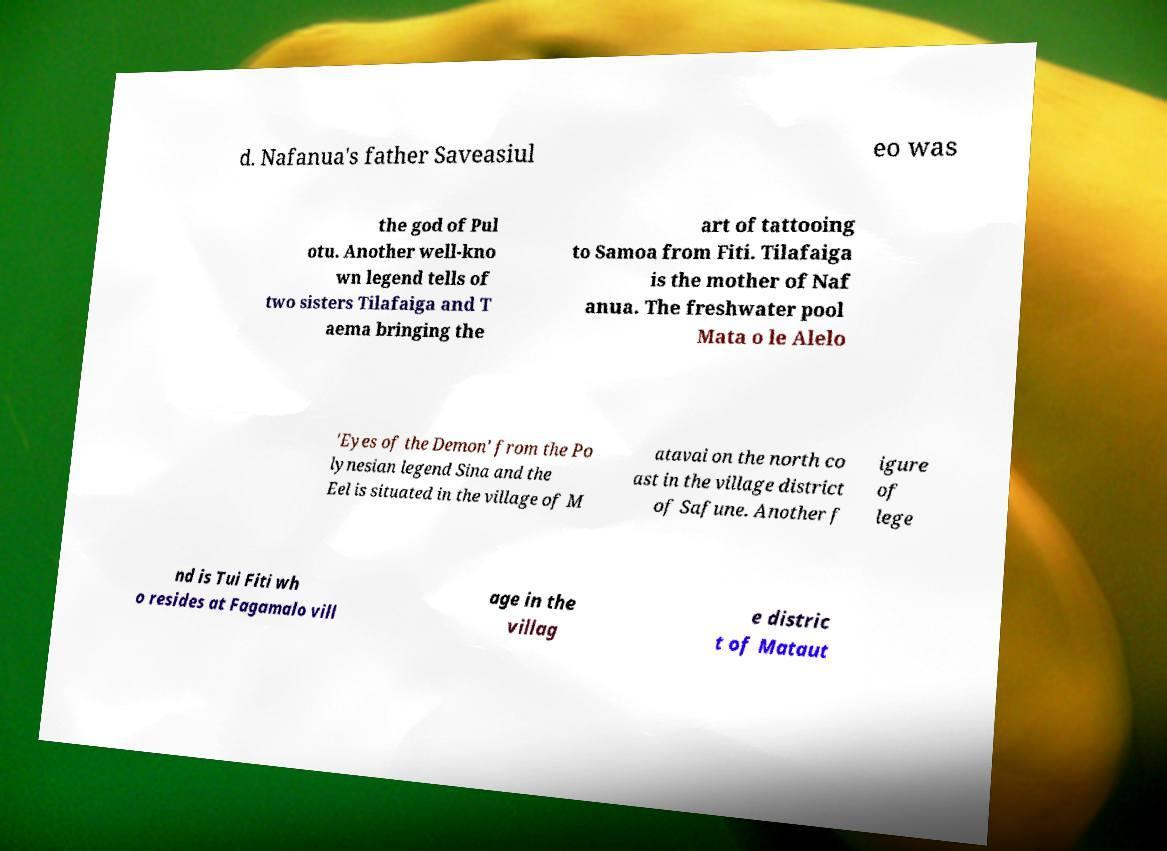Can you read and provide the text displayed in the image?This photo seems to have some interesting text. Can you extract and type it out for me? d. Nafanua's father Saveasiul eo was the god of Pul otu. Another well-kno wn legend tells of two sisters Tilafaiga and T aema bringing the art of tattooing to Samoa from Fiti. Tilafaiga is the mother of Naf anua. The freshwater pool Mata o le Alelo 'Eyes of the Demon' from the Po lynesian legend Sina and the Eel is situated in the village of M atavai on the north co ast in the village district of Safune. Another f igure of lege nd is Tui Fiti wh o resides at Fagamalo vill age in the villag e distric t of Mataut 